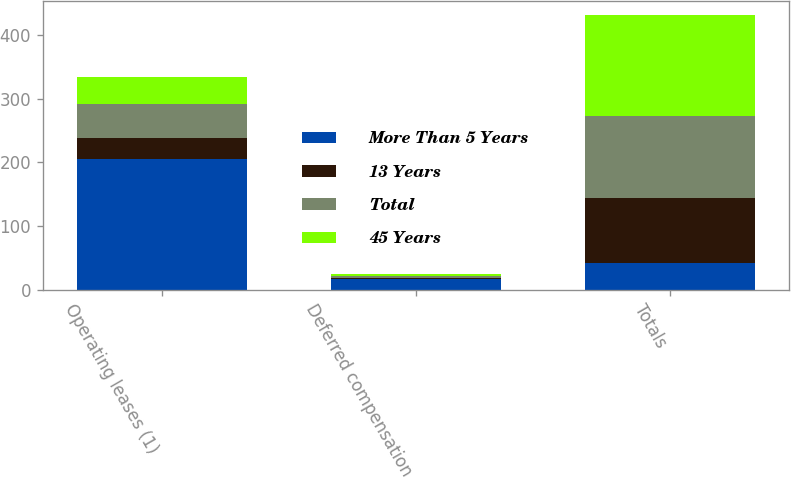Convert chart to OTSL. <chart><loc_0><loc_0><loc_500><loc_500><stacked_bar_chart><ecel><fcel>Operating leases (1)<fcel>Deferred compensation<fcel>Totals<nl><fcel>More Than 5 Years<fcel>204.9<fcel>16.6<fcel>41.2<nl><fcel>13 Years<fcel>32.7<fcel>2.3<fcel>103.3<nl><fcel>Total<fcel>54.3<fcel>2.9<fcel>128.1<nl><fcel>45 Years<fcel>41.2<fcel>2.3<fcel>158.5<nl></chart> 